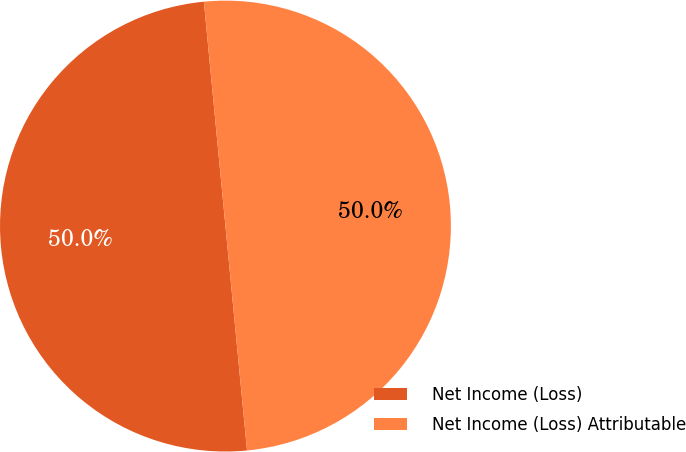Convert chart to OTSL. <chart><loc_0><loc_0><loc_500><loc_500><pie_chart><fcel>Net Income (Loss)<fcel>Net Income (Loss) Attributable<nl><fcel>50.0%<fcel>50.0%<nl></chart> 